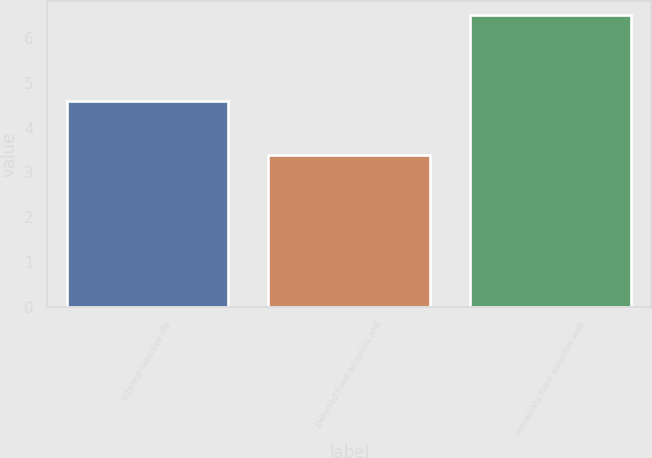Convert chart. <chart><loc_0><loc_0><loc_500><loc_500><bar_chart><fcel>Interest-sensitive life<fcel>Deferred fixed annuities and<fcel>Immediate fixed annuities with<nl><fcel>4.6<fcel>3.4<fcel>6.5<nl></chart> 